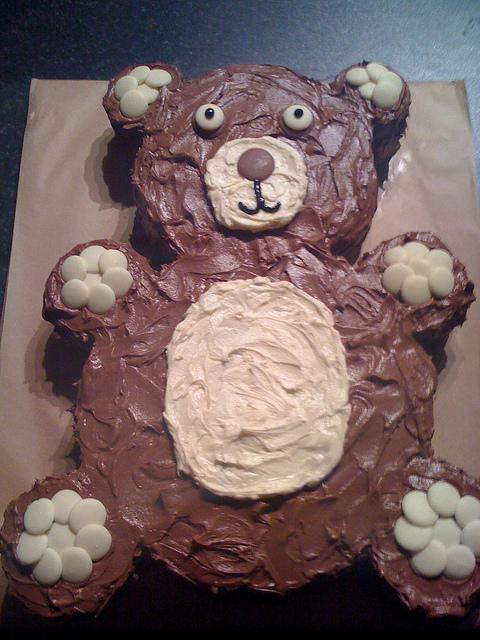How many round cakes did it take to make this bear?
Give a very brief answer. 8. How many people are in front of the tables?
Give a very brief answer. 0. 